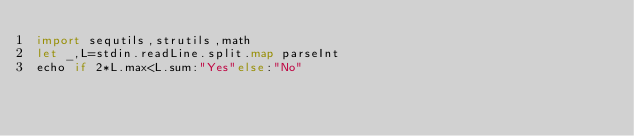Convert code to text. <code><loc_0><loc_0><loc_500><loc_500><_Nim_>import sequtils,strutils,math
let _,L=stdin.readLine.split.map parseInt
echo if 2*L.max<L.sum:"Yes"else:"No"</code> 